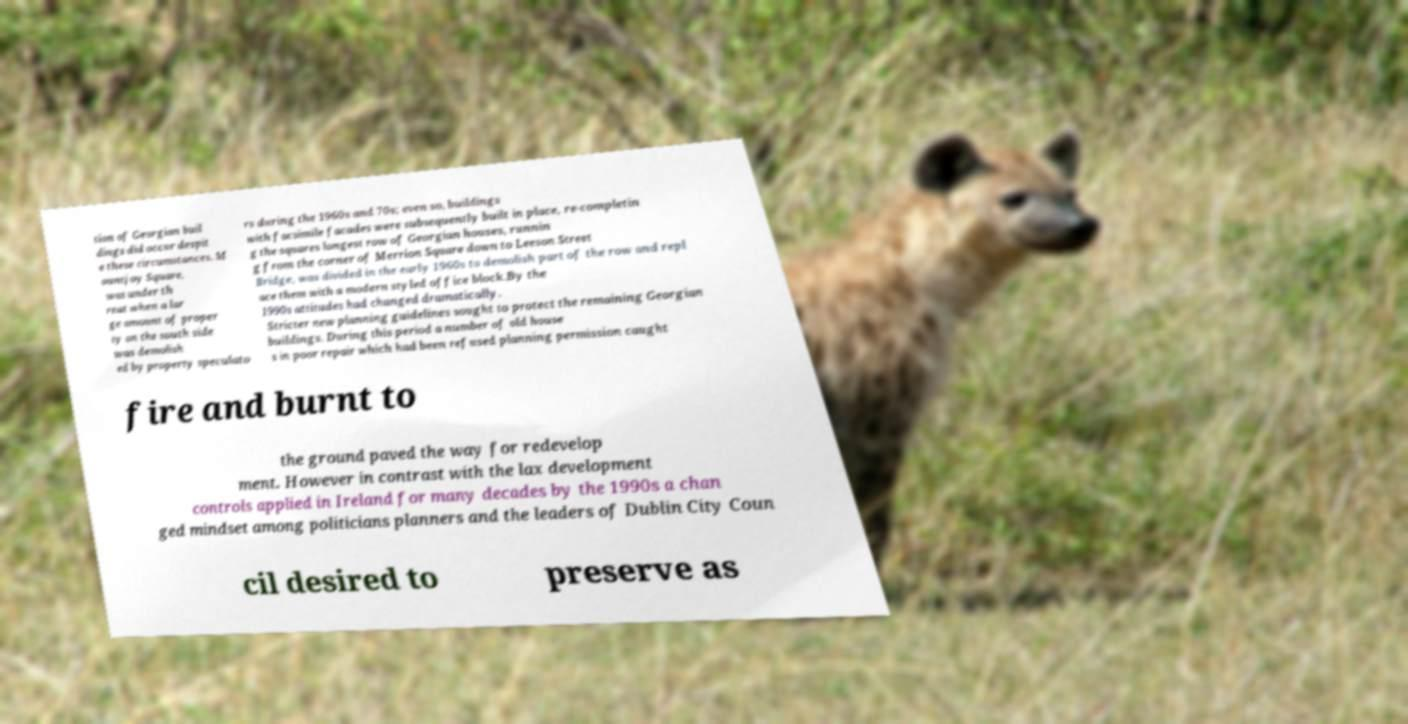Please identify and transcribe the text found in this image. tion of Georgian buil dings did occur despit e these circumstances. M ountjoy Square, was under th reat when a lar ge amount of proper ty on the south side was demolish ed by property speculato rs during the 1960s and 70s; even so, buildings with facsimile facades were subsequently built in place, re-completin g the squares longest row of Georgian houses, runnin g from the corner of Merrion Square down to Leeson Street Bridge, was divided in the early 1960s to demolish part of the row and repl ace them with a modern styled office block.By the 1990s attitudes had changed dramatically. Stricter new planning guidelines sought to protect the remaining Georgian buildings. During this period a number of old house s in poor repair which had been refused planning permission caught fire and burnt to the ground paved the way for redevelop ment. However in contrast with the lax development controls applied in Ireland for many decades by the 1990s a chan ged mindset among politicians planners and the leaders of Dublin City Coun cil desired to preserve as 